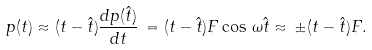<formula> <loc_0><loc_0><loc_500><loc_500>p ( t ) \approx ( t - \hat { t } ) \frac { d p ( \hat { t } ) } { d t } \, = ( t - \hat { t } ) F \cos \, \omega \hat { t } \approx \, \pm ( t - \hat { t } ) F .</formula> 